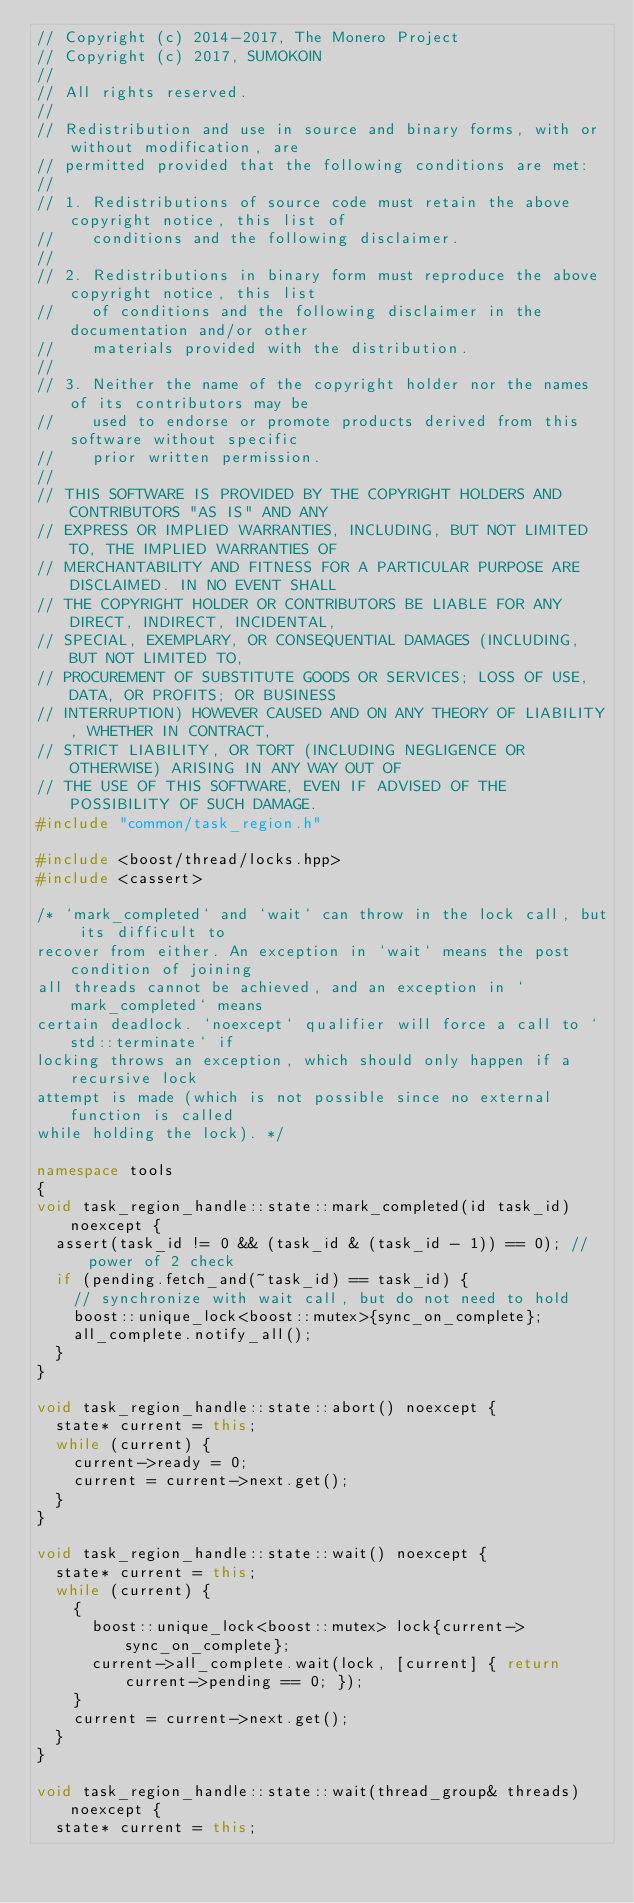Convert code to text. <code><loc_0><loc_0><loc_500><loc_500><_C++_>// Copyright (c) 2014-2017, The Monero Project
// Copyright (c) 2017, SUMOKOIN
// 
// All rights reserved.
// 
// Redistribution and use in source and binary forms, with or without modification, are
// permitted provided that the following conditions are met:
// 
// 1. Redistributions of source code must retain the above copyright notice, this list of
//    conditions and the following disclaimer.
// 
// 2. Redistributions in binary form must reproduce the above copyright notice, this list
//    of conditions and the following disclaimer in the documentation and/or other
//    materials provided with the distribution.
// 
// 3. Neither the name of the copyright holder nor the names of its contributors may be
//    used to endorse or promote products derived from this software without specific
//    prior written permission.
// 
// THIS SOFTWARE IS PROVIDED BY THE COPYRIGHT HOLDERS AND CONTRIBUTORS "AS IS" AND ANY
// EXPRESS OR IMPLIED WARRANTIES, INCLUDING, BUT NOT LIMITED TO, THE IMPLIED WARRANTIES OF
// MERCHANTABILITY AND FITNESS FOR A PARTICULAR PURPOSE ARE DISCLAIMED. IN NO EVENT SHALL
// THE COPYRIGHT HOLDER OR CONTRIBUTORS BE LIABLE FOR ANY DIRECT, INDIRECT, INCIDENTAL,
// SPECIAL, EXEMPLARY, OR CONSEQUENTIAL DAMAGES (INCLUDING, BUT NOT LIMITED TO,
// PROCUREMENT OF SUBSTITUTE GOODS OR SERVICES; LOSS OF USE, DATA, OR PROFITS; OR BUSINESS
// INTERRUPTION) HOWEVER CAUSED AND ON ANY THEORY OF LIABILITY, WHETHER IN CONTRACT,
// STRICT LIABILITY, OR TORT (INCLUDING NEGLIGENCE OR OTHERWISE) ARISING IN ANY WAY OUT OF
// THE USE OF THIS SOFTWARE, EVEN IF ADVISED OF THE POSSIBILITY OF SUCH DAMAGE.
#include "common/task_region.h"

#include <boost/thread/locks.hpp>
#include <cassert>

/* `mark_completed` and `wait` can throw in the lock call, but its difficult to
recover from either. An exception in `wait` means the post condition of joining
all threads cannot be achieved, and an exception in `mark_completed` means
certain deadlock. `noexcept` qualifier will force a call to `std::terminate` if
locking throws an exception, which should only happen if a recursive lock
attempt is made (which is not possible since no external function is called
while holding the lock). */

namespace tools
{
void task_region_handle::state::mark_completed(id task_id) noexcept {
  assert(task_id != 0 && (task_id & (task_id - 1)) == 0); // power of 2 check
  if (pending.fetch_and(~task_id) == task_id) {
    // synchronize with wait call, but do not need to hold
    boost::unique_lock<boost::mutex>{sync_on_complete};
    all_complete.notify_all();
  }
}

void task_region_handle::state::abort() noexcept {
  state* current = this;
  while (current) {
    current->ready = 0;
    current = current->next.get();
  }
}

void task_region_handle::state::wait() noexcept {
  state* current = this;
  while (current) {
    {
      boost::unique_lock<boost::mutex> lock{current->sync_on_complete};
      current->all_complete.wait(lock, [current] { return current->pending == 0; });
    }
    current = current->next.get();
  }
}

void task_region_handle::state::wait(thread_group& threads) noexcept {
  state* current = this;</code> 